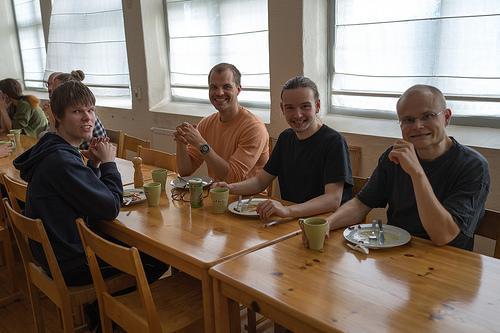How many people are wearing black shirts?
Give a very brief answer. 3. 